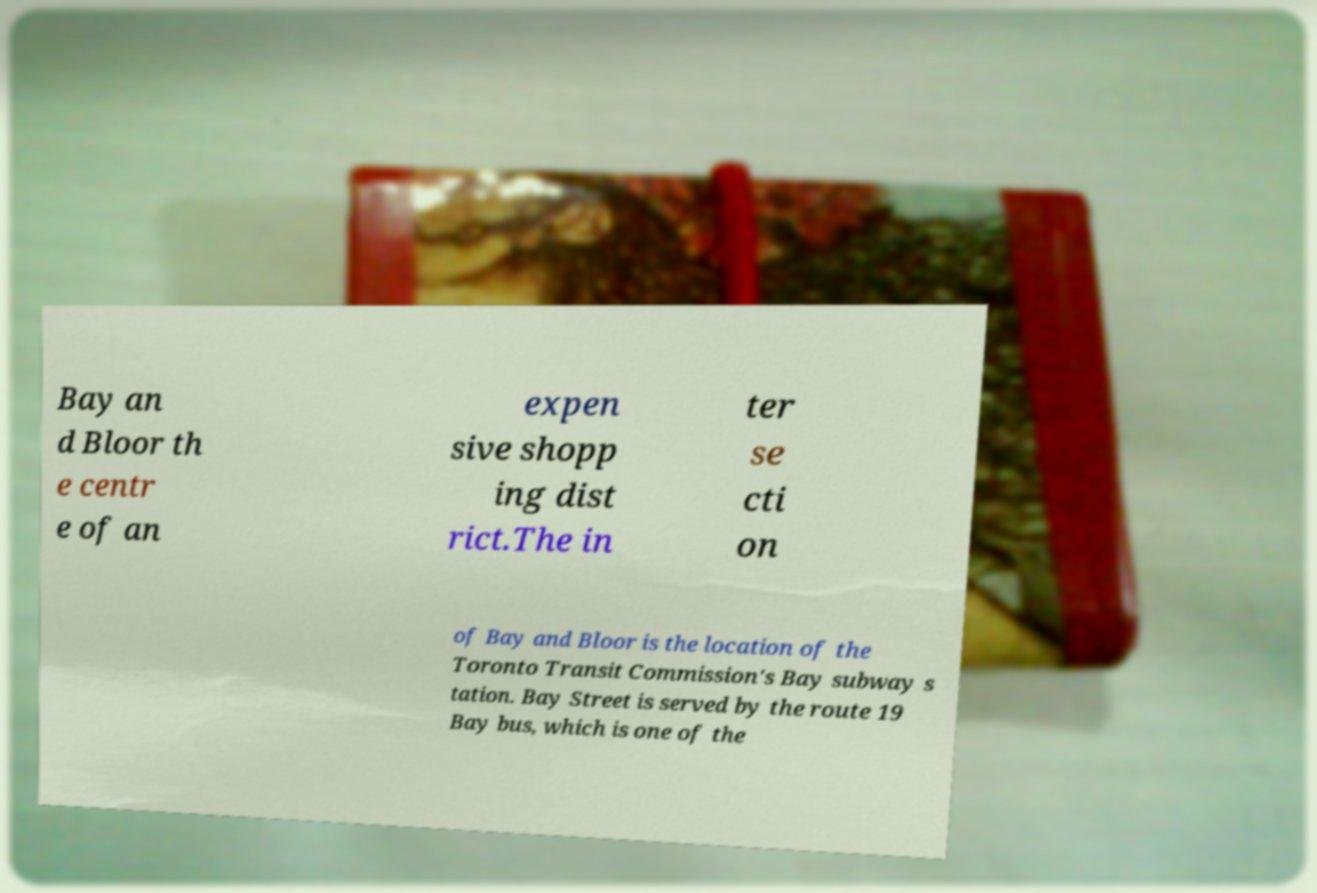What messages or text are displayed in this image? I need them in a readable, typed format. Bay an d Bloor th e centr e of an expen sive shopp ing dist rict.The in ter se cti on of Bay and Bloor is the location of the Toronto Transit Commission's Bay subway s tation. Bay Street is served by the route 19 Bay bus, which is one of the 